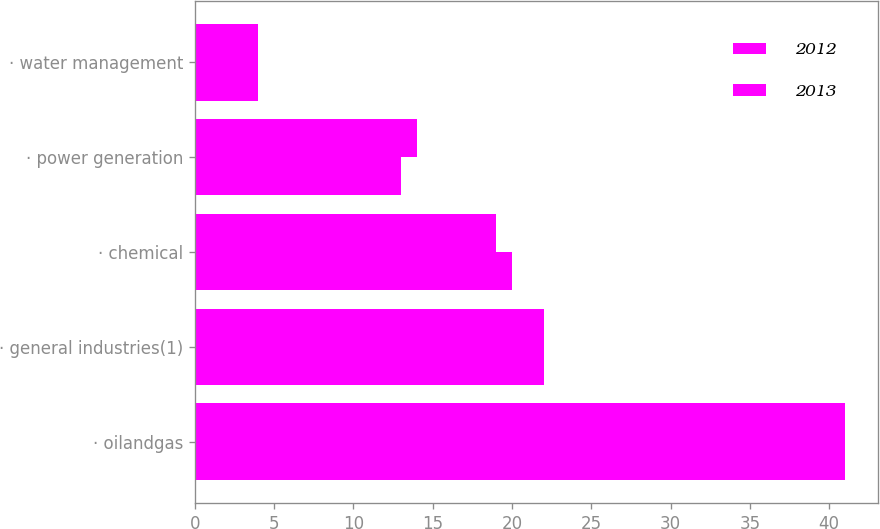Convert chart to OTSL. <chart><loc_0><loc_0><loc_500><loc_500><stacked_bar_chart><ecel><fcel>· oilandgas<fcel>· general industries(1)<fcel>· chemical<fcel>· power generation<fcel>· water management<nl><fcel>2012<fcel>41<fcel>22<fcel>20<fcel>13<fcel>4<nl><fcel>2013<fcel>41<fcel>22<fcel>19<fcel>14<fcel>4<nl></chart> 